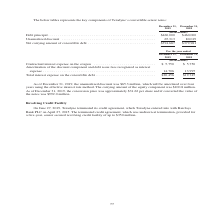According to Teradyne's financial document, What was the unamortized discount in 2019? According to the financial document, $65.3 million. The relevant text states: "of December 31, 2019, the unamortized discount was $65.3 million, which will be amortized over four years using the effective interest rate method. The carrying amo..." Also, What was the carrying amount of the equity component? According to the financial document, $100.8 million. The relevant text states: "d. The carrying amount of the equity component was $100.8 million. As of December 31, 2019, the conversion price was approximately $31.62 per share and if converted..." Also, What were the key components of Teradyne’s convertible senior notes in the table? The document contains multiple relevant values: Debt principal, Unamortized discount, Net carrying amount of convertible debt. From the document: "(in thousands) Debt principal . $460,000 $460,000 Unamortized discount . 65,313 80,019 (in thousands) Debt principal . $460,000 $460,000 Unamortized d..." Additionally, In which year was the amount of Unamortized discount larger? According to the financial document, 2018. The relevant text states: "December 31, 2018..." Also, can you calculate: What was the change in Debt principal from 2018 to 2019? I cannot find a specific answer to this question in the financial document. Also, can you calculate: What was the percentage change in Debt principal from 2018 to 2019? I cannot find a specific answer to this question in the financial document. 